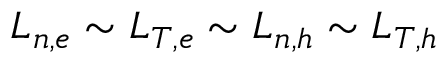Convert formula to latex. <formula><loc_0><loc_0><loc_500><loc_500>L _ { n , e } \sim L _ { T , e } \sim L _ { n , h } \sim L _ { T , h }</formula> 